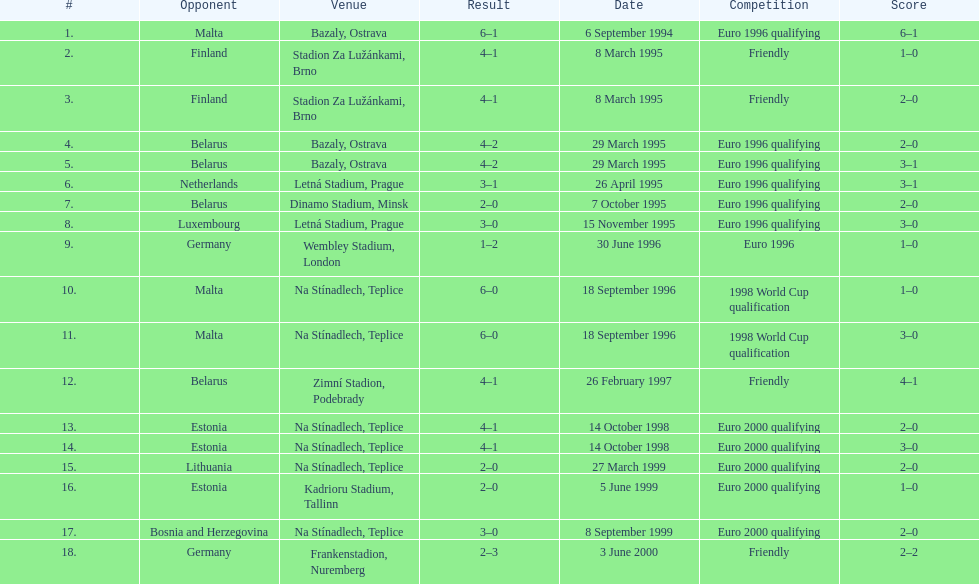List the opponents which are under the friendly competition. Finland, Belarus, Germany. 